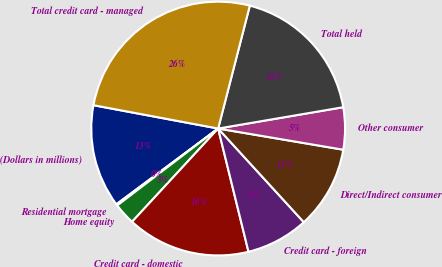<chart> <loc_0><loc_0><loc_500><loc_500><pie_chart><fcel>(Dollars in millions)<fcel>Residential mortgage<fcel>Home equity<fcel>Credit card - domestic<fcel>Credit card - foreign<fcel>Direct/Indirect consumer<fcel>Other consumer<fcel>Total held<fcel>Total credit card - managed<nl><fcel>13.13%<fcel>0.18%<fcel>2.77%<fcel>15.71%<fcel>7.95%<fcel>10.54%<fcel>5.36%<fcel>18.3%<fcel>26.07%<nl></chart> 